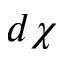Convert formula to latex. <formula><loc_0><loc_0><loc_500><loc_500>d \chi</formula> 